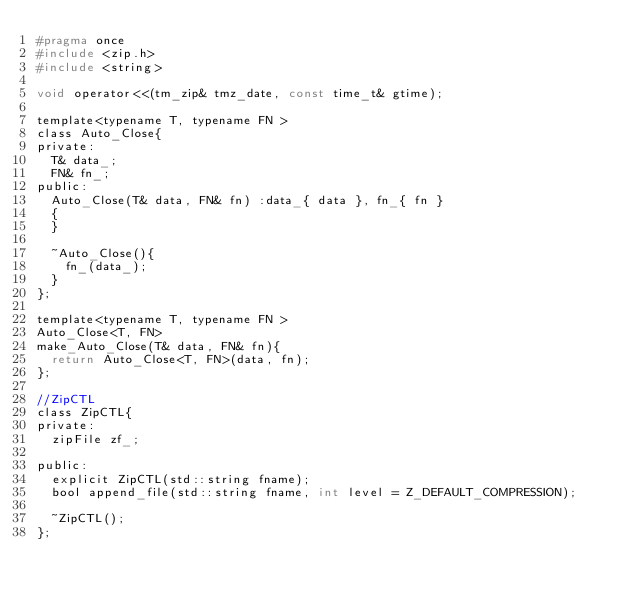<code> <loc_0><loc_0><loc_500><loc_500><_C_>#pragma once
#include <zip.h>
#include <string>

void operator<<(tm_zip& tmz_date, const time_t& gtime);

template<typename T, typename FN >
class Auto_Close{
private:
	T& data_;
	FN& fn_;
public:
	Auto_Close(T& data, FN& fn) :data_{ data }, fn_{ fn }
	{
	}

	~Auto_Close(){
		fn_(data_);
	}
};

template<typename T, typename FN >
Auto_Close<T, FN> 
make_Auto_Close(T& data, FN& fn){
	return Auto_Close<T, FN>(data, fn);
};

//ZipCTL
class ZipCTL{
private:
	zipFile zf_;
	
public:
	explicit ZipCTL(std::string fname);
	bool append_file(std::string fname, int level = Z_DEFAULT_COMPRESSION);

	~ZipCTL();
};


</code> 